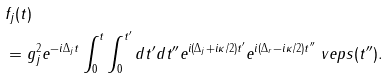<formula> <loc_0><loc_0><loc_500><loc_500>& f _ { j } ( t ) \\ & = g _ { j } ^ { 2 } e ^ { - i \Delta _ { j } t } \int _ { 0 } ^ { t } \int _ { 0 } ^ { t ^ { \prime } } d t ^ { \prime } d t ^ { \prime \prime } e ^ { i ( \Delta _ { j } + i \kappa / 2 ) t ^ { \prime } } e ^ { i ( \Delta _ { r } - i \kappa / 2 ) t ^ { \prime \prime } } \ v e p s ( t ^ { \prime \prime } ) .</formula> 